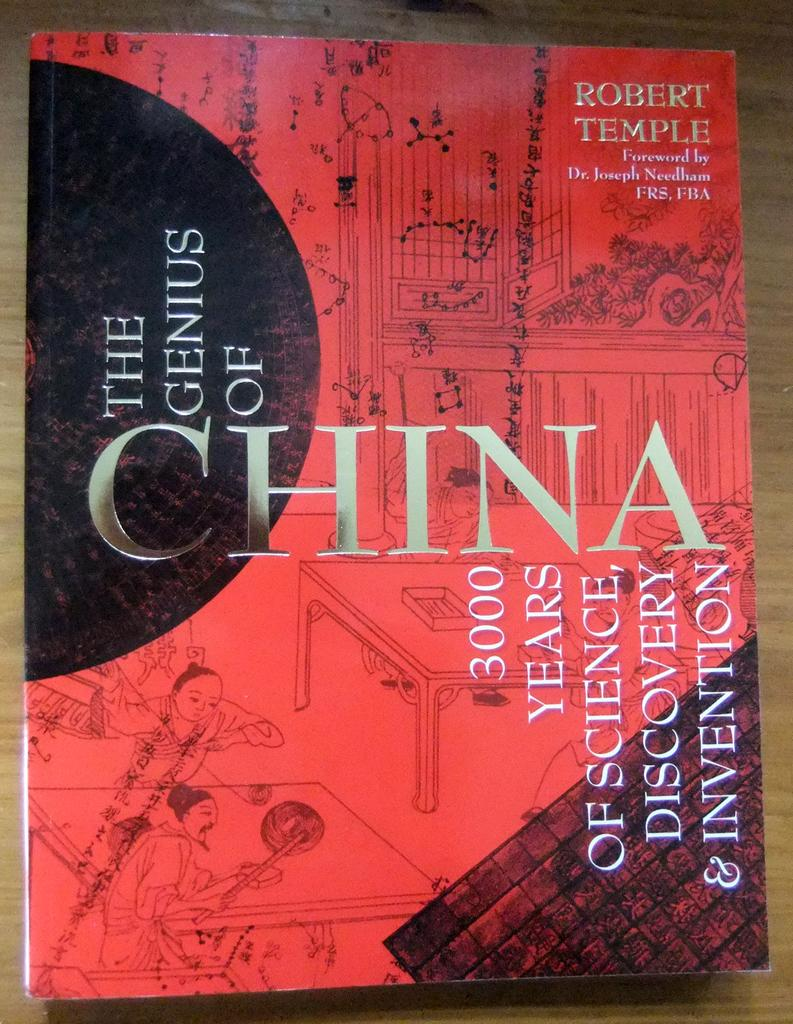Provide a one-sentence caption for the provided image. The genius of China book sits on a wooden table alone. 